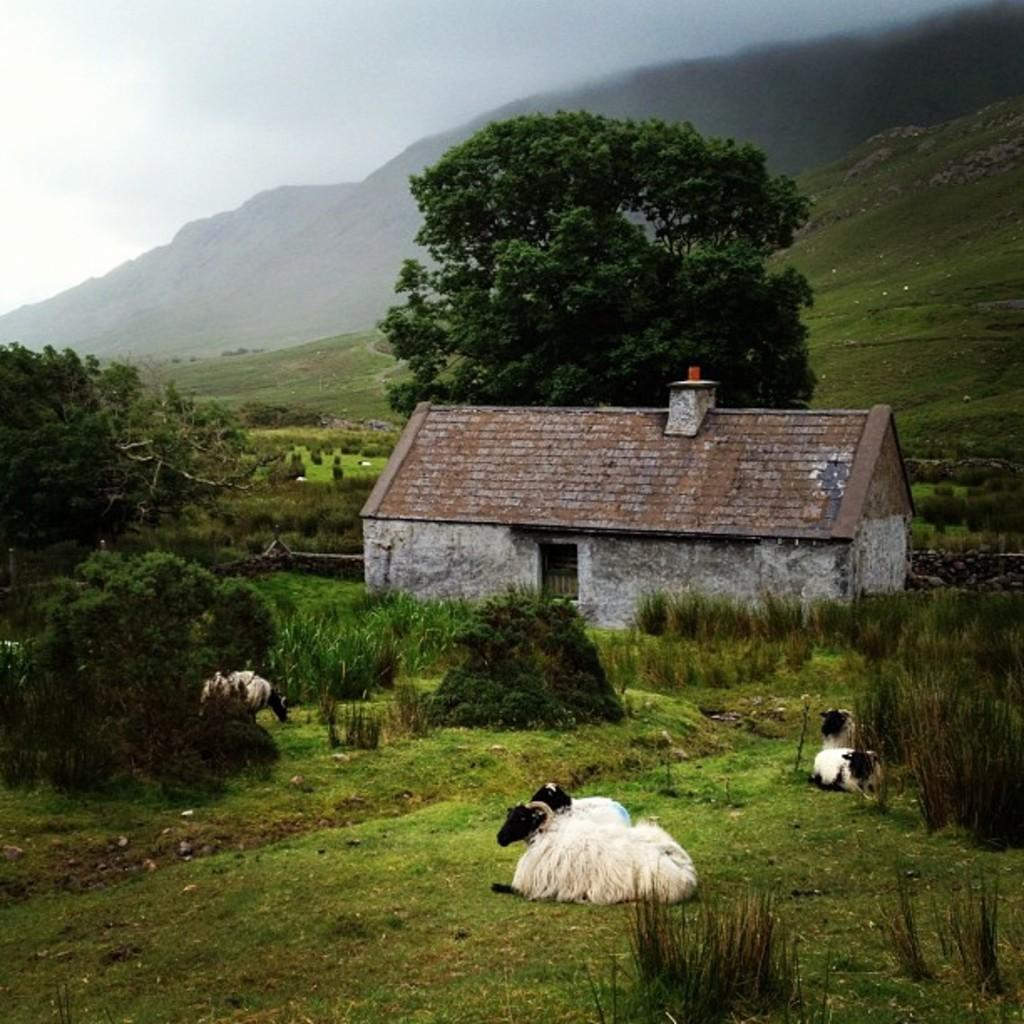What animals are present in the image? There are cattle in the image. What are the cattle doing in the image? The cattle are sitting on the grass. What can be seen in the background of the image? There are trees, a house, and mountains in the background of the image. What type of test can be seen being conducted on the potato in the image? There is no potato or test present in the image; it features cattle sitting on the grass with a background of trees, a house, and mountains. 